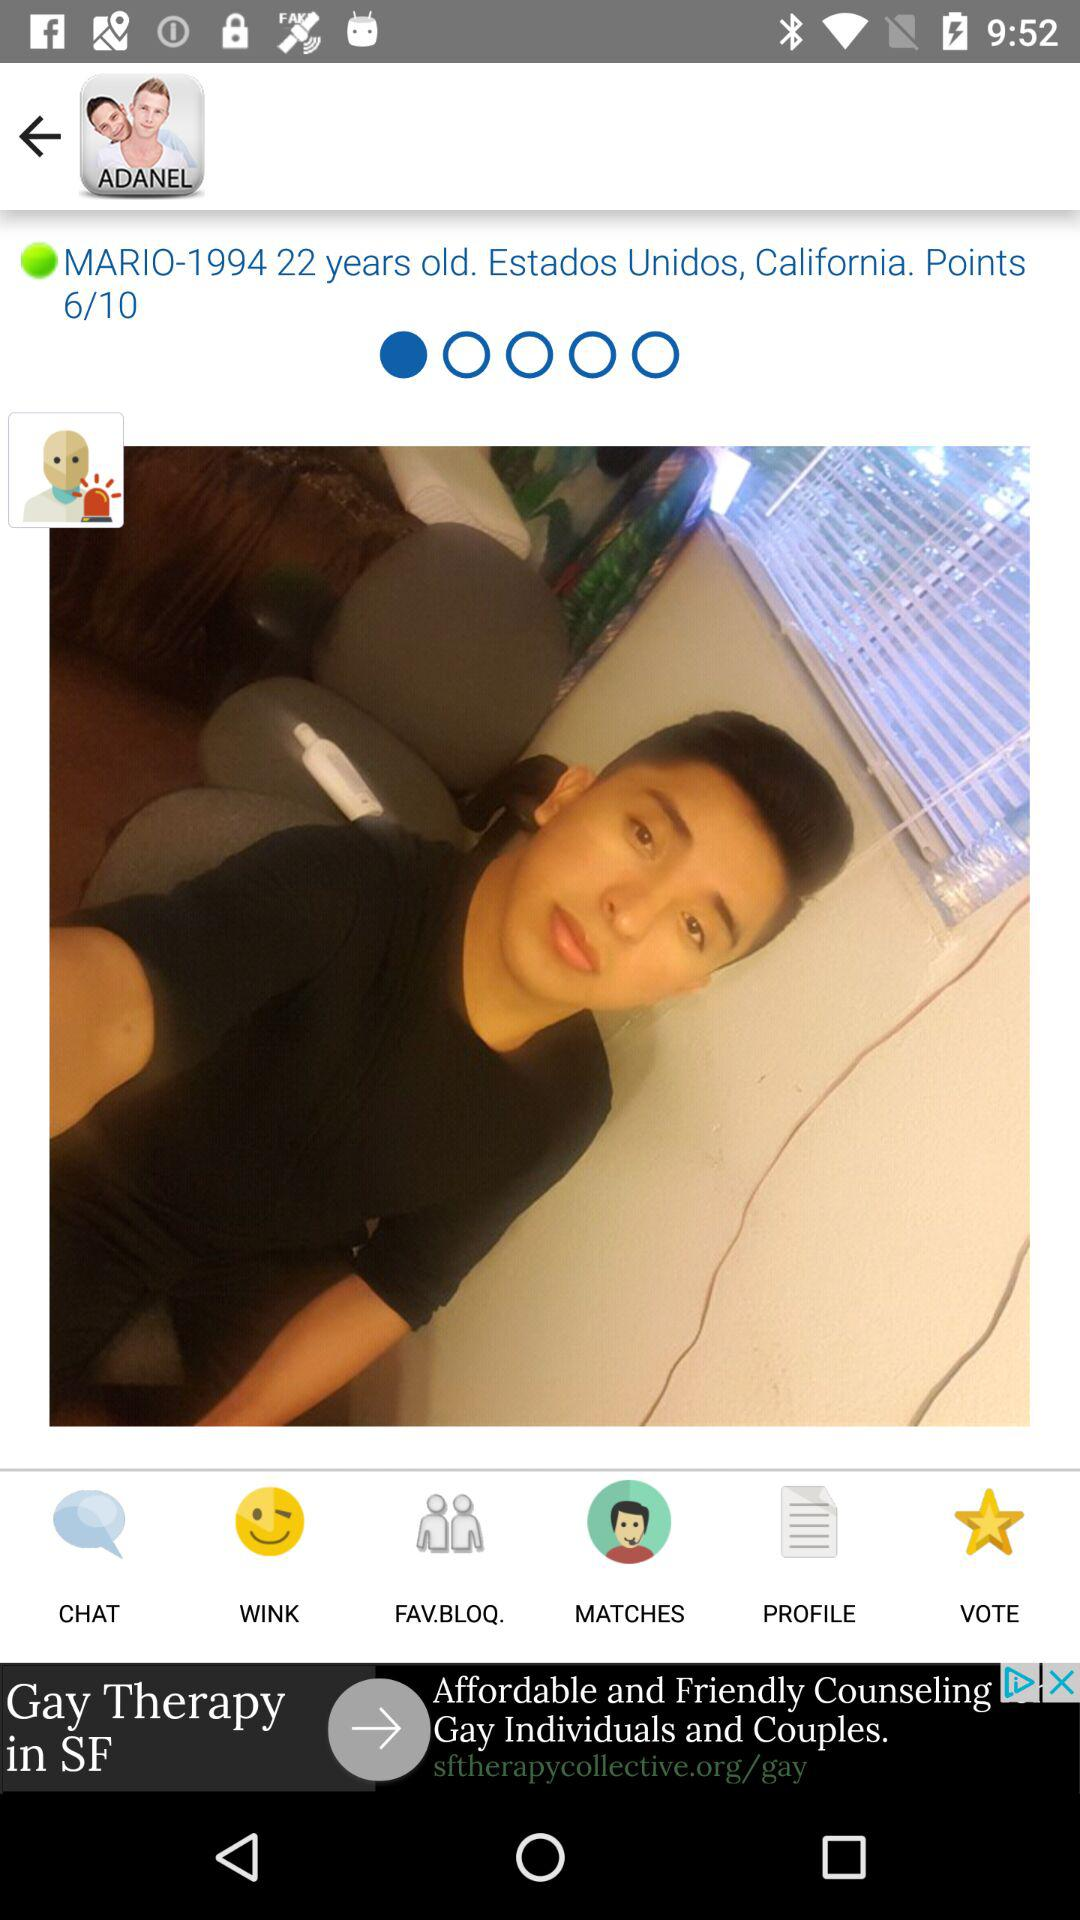How many years old is Mario?
Answer the question using a single word or phrase. 22 